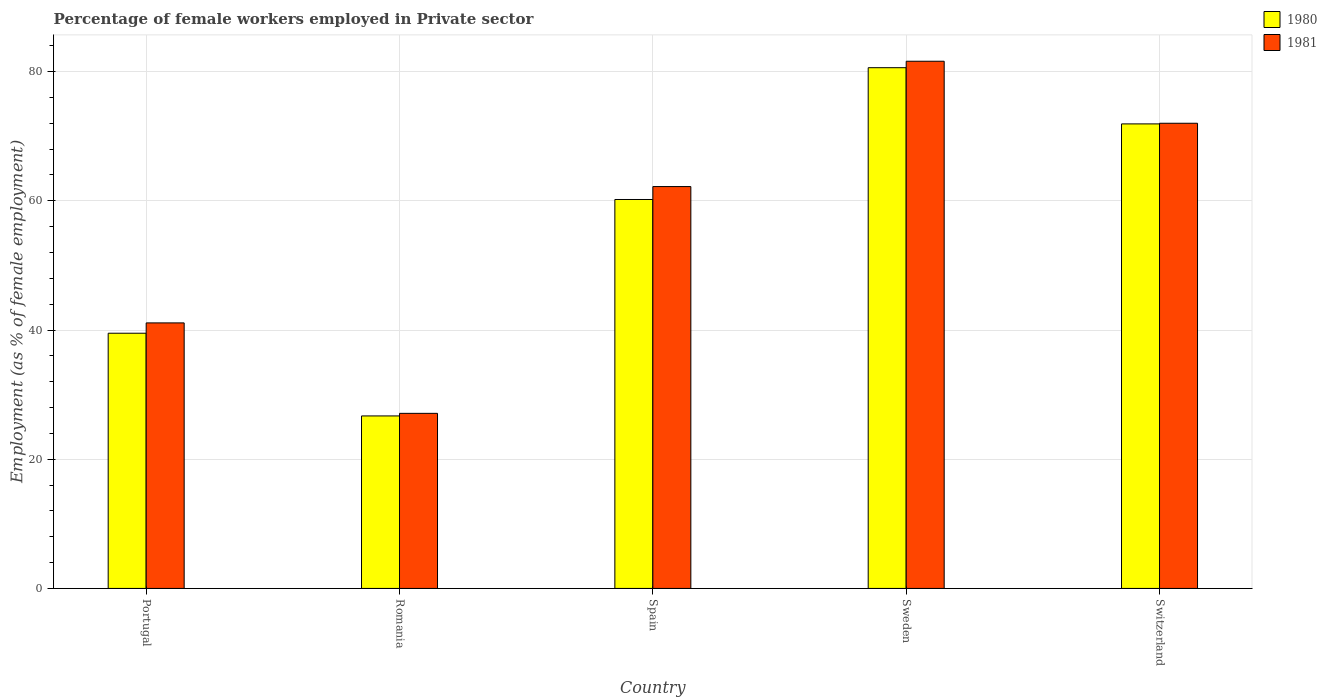Are the number of bars per tick equal to the number of legend labels?
Provide a short and direct response. Yes. In how many cases, is the number of bars for a given country not equal to the number of legend labels?
Your response must be concise. 0. What is the percentage of females employed in Private sector in 1980 in Portugal?
Keep it short and to the point. 39.5. Across all countries, what is the maximum percentage of females employed in Private sector in 1981?
Offer a terse response. 81.6. Across all countries, what is the minimum percentage of females employed in Private sector in 1980?
Keep it short and to the point. 26.7. In which country was the percentage of females employed in Private sector in 1981 maximum?
Provide a short and direct response. Sweden. In which country was the percentage of females employed in Private sector in 1981 minimum?
Provide a short and direct response. Romania. What is the total percentage of females employed in Private sector in 1980 in the graph?
Your answer should be compact. 278.9. What is the difference between the percentage of females employed in Private sector in 1980 in Sweden and that in Switzerland?
Keep it short and to the point. 8.7. What is the difference between the percentage of females employed in Private sector in 1980 in Portugal and the percentage of females employed in Private sector in 1981 in Spain?
Keep it short and to the point. -22.7. What is the average percentage of females employed in Private sector in 1980 per country?
Offer a very short reply. 55.78. What is the difference between the percentage of females employed in Private sector of/in 1981 and percentage of females employed in Private sector of/in 1980 in Portugal?
Provide a succinct answer. 1.6. In how many countries, is the percentage of females employed in Private sector in 1981 greater than 40 %?
Your response must be concise. 4. What is the ratio of the percentage of females employed in Private sector in 1981 in Sweden to that in Switzerland?
Keep it short and to the point. 1.13. Is the difference between the percentage of females employed in Private sector in 1981 in Spain and Sweden greater than the difference between the percentage of females employed in Private sector in 1980 in Spain and Sweden?
Your response must be concise. Yes. What is the difference between the highest and the second highest percentage of females employed in Private sector in 1981?
Keep it short and to the point. -9.6. What is the difference between the highest and the lowest percentage of females employed in Private sector in 1981?
Your response must be concise. 54.5. How many countries are there in the graph?
Offer a terse response. 5. What is the difference between two consecutive major ticks on the Y-axis?
Make the answer very short. 20. Are the values on the major ticks of Y-axis written in scientific E-notation?
Provide a succinct answer. No. Where does the legend appear in the graph?
Offer a very short reply. Top right. How are the legend labels stacked?
Your answer should be compact. Vertical. What is the title of the graph?
Make the answer very short. Percentage of female workers employed in Private sector. What is the label or title of the X-axis?
Provide a succinct answer. Country. What is the label or title of the Y-axis?
Provide a succinct answer. Employment (as % of female employment). What is the Employment (as % of female employment) of 1980 in Portugal?
Ensure brevity in your answer.  39.5. What is the Employment (as % of female employment) in 1981 in Portugal?
Keep it short and to the point. 41.1. What is the Employment (as % of female employment) in 1980 in Romania?
Provide a succinct answer. 26.7. What is the Employment (as % of female employment) in 1981 in Romania?
Your answer should be compact. 27.1. What is the Employment (as % of female employment) of 1980 in Spain?
Offer a terse response. 60.2. What is the Employment (as % of female employment) of 1981 in Spain?
Give a very brief answer. 62.2. What is the Employment (as % of female employment) in 1980 in Sweden?
Offer a very short reply. 80.6. What is the Employment (as % of female employment) of 1981 in Sweden?
Make the answer very short. 81.6. What is the Employment (as % of female employment) in 1980 in Switzerland?
Offer a very short reply. 71.9. Across all countries, what is the maximum Employment (as % of female employment) of 1980?
Make the answer very short. 80.6. Across all countries, what is the maximum Employment (as % of female employment) of 1981?
Your response must be concise. 81.6. Across all countries, what is the minimum Employment (as % of female employment) in 1980?
Offer a very short reply. 26.7. Across all countries, what is the minimum Employment (as % of female employment) in 1981?
Give a very brief answer. 27.1. What is the total Employment (as % of female employment) in 1980 in the graph?
Provide a short and direct response. 278.9. What is the total Employment (as % of female employment) in 1981 in the graph?
Offer a very short reply. 284. What is the difference between the Employment (as % of female employment) in 1980 in Portugal and that in Romania?
Your answer should be compact. 12.8. What is the difference between the Employment (as % of female employment) of 1980 in Portugal and that in Spain?
Your answer should be compact. -20.7. What is the difference between the Employment (as % of female employment) in 1981 in Portugal and that in Spain?
Provide a succinct answer. -21.1. What is the difference between the Employment (as % of female employment) in 1980 in Portugal and that in Sweden?
Provide a short and direct response. -41.1. What is the difference between the Employment (as % of female employment) in 1981 in Portugal and that in Sweden?
Provide a short and direct response. -40.5. What is the difference between the Employment (as % of female employment) of 1980 in Portugal and that in Switzerland?
Keep it short and to the point. -32.4. What is the difference between the Employment (as % of female employment) of 1981 in Portugal and that in Switzerland?
Offer a terse response. -30.9. What is the difference between the Employment (as % of female employment) in 1980 in Romania and that in Spain?
Give a very brief answer. -33.5. What is the difference between the Employment (as % of female employment) in 1981 in Romania and that in Spain?
Keep it short and to the point. -35.1. What is the difference between the Employment (as % of female employment) in 1980 in Romania and that in Sweden?
Provide a succinct answer. -53.9. What is the difference between the Employment (as % of female employment) in 1981 in Romania and that in Sweden?
Offer a terse response. -54.5. What is the difference between the Employment (as % of female employment) in 1980 in Romania and that in Switzerland?
Ensure brevity in your answer.  -45.2. What is the difference between the Employment (as % of female employment) in 1981 in Romania and that in Switzerland?
Keep it short and to the point. -44.9. What is the difference between the Employment (as % of female employment) of 1980 in Spain and that in Sweden?
Offer a very short reply. -20.4. What is the difference between the Employment (as % of female employment) of 1981 in Spain and that in Sweden?
Your answer should be very brief. -19.4. What is the difference between the Employment (as % of female employment) in 1980 in Spain and that in Switzerland?
Provide a succinct answer. -11.7. What is the difference between the Employment (as % of female employment) in 1981 in Spain and that in Switzerland?
Provide a succinct answer. -9.8. What is the difference between the Employment (as % of female employment) in 1980 in Sweden and that in Switzerland?
Give a very brief answer. 8.7. What is the difference between the Employment (as % of female employment) in 1980 in Portugal and the Employment (as % of female employment) in 1981 in Romania?
Your response must be concise. 12.4. What is the difference between the Employment (as % of female employment) of 1980 in Portugal and the Employment (as % of female employment) of 1981 in Spain?
Keep it short and to the point. -22.7. What is the difference between the Employment (as % of female employment) of 1980 in Portugal and the Employment (as % of female employment) of 1981 in Sweden?
Keep it short and to the point. -42.1. What is the difference between the Employment (as % of female employment) in 1980 in Portugal and the Employment (as % of female employment) in 1981 in Switzerland?
Keep it short and to the point. -32.5. What is the difference between the Employment (as % of female employment) of 1980 in Romania and the Employment (as % of female employment) of 1981 in Spain?
Your response must be concise. -35.5. What is the difference between the Employment (as % of female employment) of 1980 in Romania and the Employment (as % of female employment) of 1981 in Sweden?
Offer a very short reply. -54.9. What is the difference between the Employment (as % of female employment) in 1980 in Romania and the Employment (as % of female employment) in 1981 in Switzerland?
Your answer should be very brief. -45.3. What is the difference between the Employment (as % of female employment) in 1980 in Spain and the Employment (as % of female employment) in 1981 in Sweden?
Your answer should be compact. -21.4. What is the difference between the Employment (as % of female employment) in 1980 in Sweden and the Employment (as % of female employment) in 1981 in Switzerland?
Make the answer very short. 8.6. What is the average Employment (as % of female employment) of 1980 per country?
Make the answer very short. 55.78. What is the average Employment (as % of female employment) in 1981 per country?
Offer a very short reply. 56.8. What is the difference between the Employment (as % of female employment) in 1980 and Employment (as % of female employment) in 1981 in Romania?
Provide a succinct answer. -0.4. What is the ratio of the Employment (as % of female employment) in 1980 in Portugal to that in Romania?
Ensure brevity in your answer.  1.48. What is the ratio of the Employment (as % of female employment) in 1981 in Portugal to that in Romania?
Your answer should be compact. 1.52. What is the ratio of the Employment (as % of female employment) of 1980 in Portugal to that in Spain?
Provide a succinct answer. 0.66. What is the ratio of the Employment (as % of female employment) in 1981 in Portugal to that in Spain?
Provide a short and direct response. 0.66. What is the ratio of the Employment (as % of female employment) in 1980 in Portugal to that in Sweden?
Make the answer very short. 0.49. What is the ratio of the Employment (as % of female employment) in 1981 in Portugal to that in Sweden?
Your response must be concise. 0.5. What is the ratio of the Employment (as % of female employment) of 1980 in Portugal to that in Switzerland?
Your answer should be very brief. 0.55. What is the ratio of the Employment (as % of female employment) in 1981 in Portugal to that in Switzerland?
Offer a terse response. 0.57. What is the ratio of the Employment (as % of female employment) in 1980 in Romania to that in Spain?
Keep it short and to the point. 0.44. What is the ratio of the Employment (as % of female employment) of 1981 in Romania to that in Spain?
Keep it short and to the point. 0.44. What is the ratio of the Employment (as % of female employment) of 1980 in Romania to that in Sweden?
Your answer should be compact. 0.33. What is the ratio of the Employment (as % of female employment) of 1981 in Romania to that in Sweden?
Provide a succinct answer. 0.33. What is the ratio of the Employment (as % of female employment) in 1980 in Romania to that in Switzerland?
Your response must be concise. 0.37. What is the ratio of the Employment (as % of female employment) in 1981 in Romania to that in Switzerland?
Offer a terse response. 0.38. What is the ratio of the Employment (as % of female employment) of 1980 in Spain to that in Sweden?
Give a very brief answer. 0.75. What is the ratio of the Employment (as % of female employment) of 1981 in Spain to that in Sweden?
Provide a succinct answer. 0.76. What is the ratio of the Employment (as % of female employment) of 1980 in Spain to that in Switzerland?
Give a very brief answer. 0.84. What is the ratio of the Employment (as % of female employment) in 1981 in Spain to that in Switzerland?
Provide a succinct answer. 0.86. What is the ratio of the Employment (as % of female employment) of 1980 in Sweden to that in Switzerland?
Ensure brevity in your answer.  1.12. What is the ratio of the Employment (as % of female employment) in 1981 in Sweden to that in Switzerland?
Keep it short and to the point. 1.13. What is the difference between the highest and the second highest Employment (as % of female employment) in 1980?
Provide a short and direct response. 8.7. What is the difference between the highest and the second highest Employment (as % of female employment) of 1981?
Provide a succinct answer. 9.6. What is the difference between the highest and the lowest Employment (as % of female employment) in 1980?
Give a very brief answer. 53.9. What is the difference between the highest and the lowest Employment (as % of female employment) in 1981?
Your answer should be compact. 54.5. 